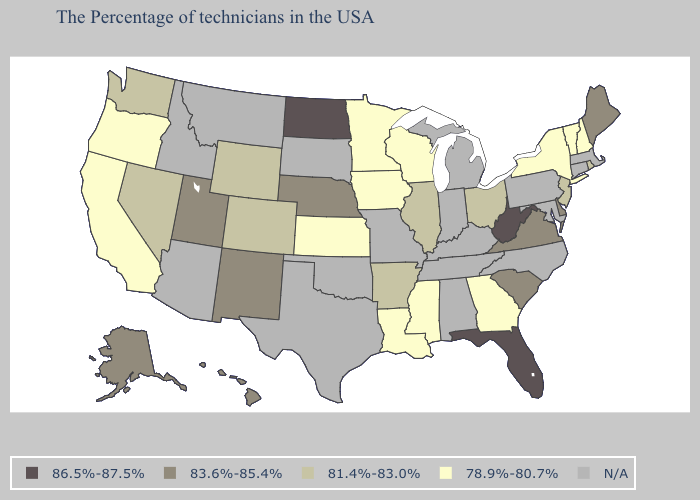Does Maine have the lowest value in the Northeast?
Quick response, please. No. What is the lowest value in the MidWest?
Short answer required. 78.9%-80.7%. What is the value of Maryland?
Concise answer only. N/A. Among the states that border Mississippi , does Louisiana have the lowest value?
Answer briefly. Yes. What is the highest value in the West ?
Give a very brief answer. 83.6%-85.4%. Among the states that border Iowa , does Illinois have the lowest value?
Write a very short answer. No. What is the lowest value in the West?
Give a very brief answer. 78.9%-80.7%. What is the lowest value in the Northeast?
Be succinct. 78.9%-80.7%. Which states have the lowest value in the USA?
Quick response, please. New Hampshire, Vermont, New York, Georgia, Wisconsin, Mississippi, Louisiana, Minnesota, Iowa, Kansas, California, Oregon. Name the states that have a value in the range 78.9%-80.7%?
Be succinct. New Hampshire, Vermont, New York, Georgia, Wisconsin, Mississippi, Louisiana, Minnesota, Iowa, Kansas, California, Oregon. What is the highest value in the MidWest ?
Keep it brief. 86.5%-87.5%. What is the highest value in states that border Connecticut?
Answer briefly. 81.4%-83.0%. How many symbols are there in the legend?
Be succinct. 5. Does the map have missing data?
Give a very brief answer. Yes. Which states have the lowest value in the USA?
Quick response, please. New Hampshire, Vermont, New York, Georgia, Wisconsin, Mississippi, Louisiana, Minnesota, Iowa, Kansas, California, Oregon. 